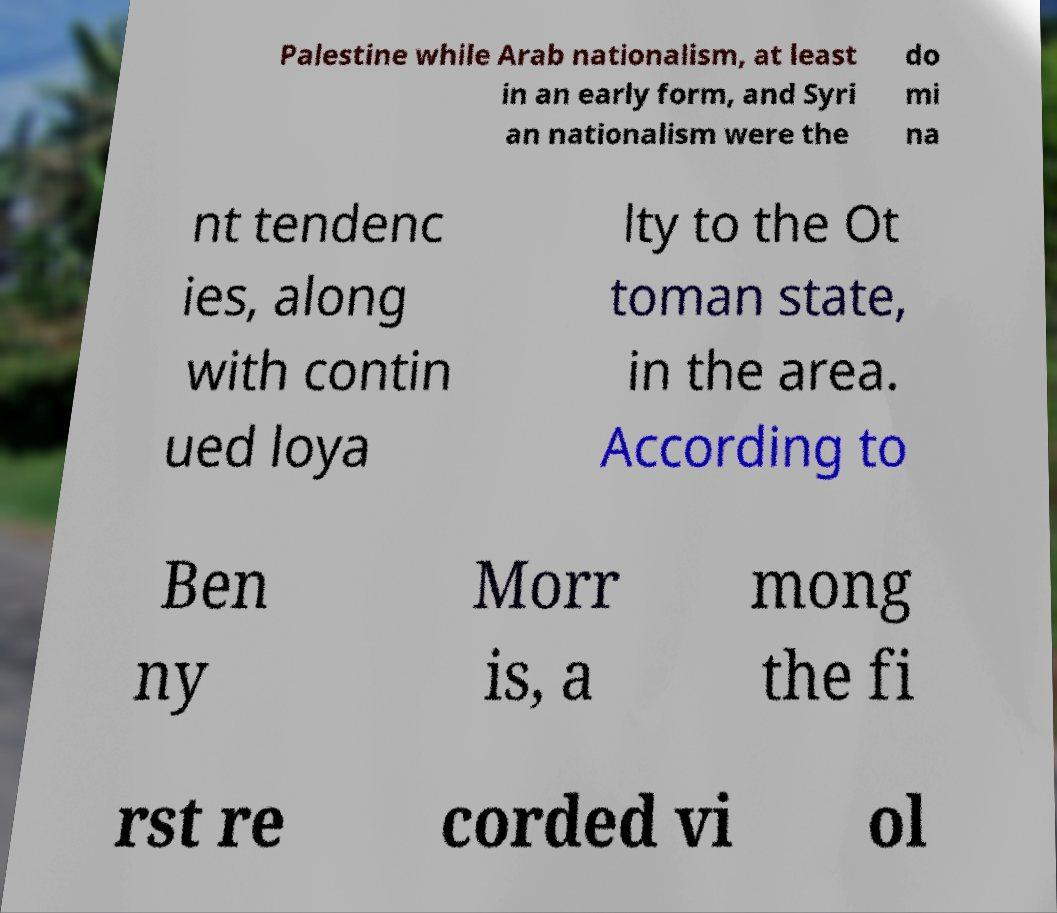What messages or text are displayed in this image? I need them in a readable, typed format. Palestine while Arab nationalism, at least in an early form, and Syri an nationalism were the do mi na nt tendenc ies, along with contin ued loya lty to the Ot toman state, in the area. According to Ben ny Morr is, a mong the fi rst re corded vi ol 